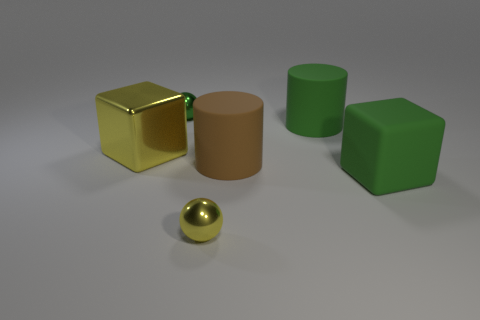Are there an equal number of tiny yellow metallic things behind the rubber cube and large brown matte things that are behind the big yellow cube?
Ensure brevity in your answer.  Yes. Is there any other thing that is the same size as the green cylinder?
Your answer should be compact. Yes. There is a block that is the same material as the big brown cylinder; what is its color?
Your answer should be very brief. Green. Do the large yellow object and the sphere that is on the left side of the yellow sphere have the same material?
Ensure brevity in your answer.  Yes. The matte thing that is both on the right side of the big brown rubber thing and in front of the green matte cylinder is what color?
Your response must be concise. Green. What number of balls are either tiny green things or tiny cyan objects?
Give a very brief answer. 1. There is a tiny green metallic thing; is its shape the same as the rubber object that is to the left of the big green cylinder?
Your response must be concise. No. How big is the metallic thing that is right of the big yellow metal thing and behind the green rubber cube?
Provide a short and direct response. Small. What shape is the tiny green object?
Offer a very short reply. Sphere. There is a metallic object on the right side of the green metallic sphere; is there a small ball that is on the right side of it?
Ensure brevity in your answer.  No. 